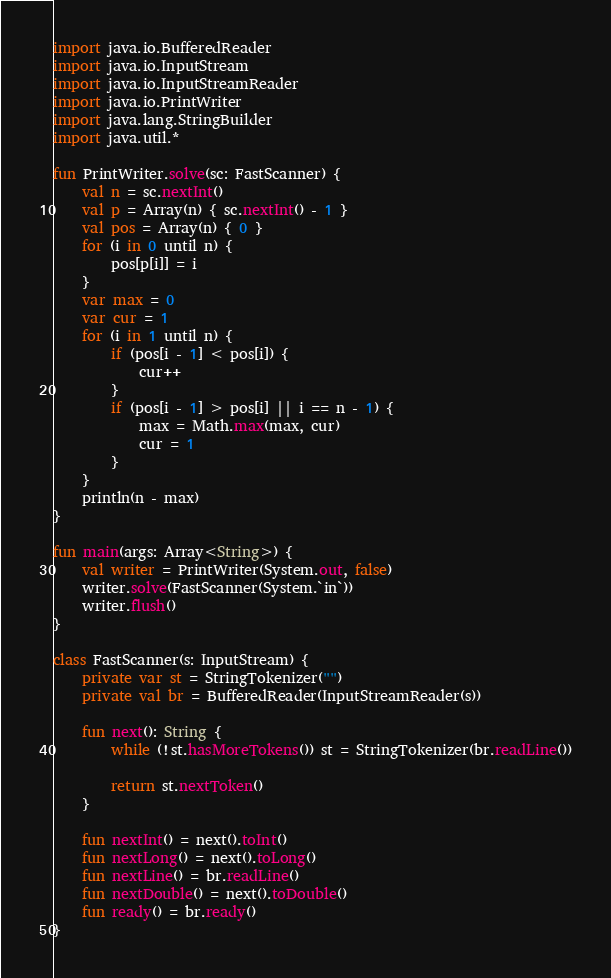<code> <loc_0><loc_0><loc_500><loc_500><_Kotlin_>import java.io.BufferedReader
import java.io.InputStream
import java.io.InputStreamReader
import java.io.PrintWriter
import java.lang.StringBuilder
import java.util.*

fun PrintWriter.solve(sc: FastScanner) {
    val n = sc.nextInt()
    val p = Array(n) { sc.nextInt() - 1 }
    val pos = Array(n) { 0 }
    for (i in 0 until n) {
        pos[p[i]] = i
    }
    var max = 0
    var cur = 1
    for (i in 1 until n) {
        if (pos[i - 1] < pos[i]) {
            cur++
        }
        if (pos[i - 1] > pos[i] || i == n - 1) {
            max = Math.max(max, cur)
            cur = 1
        }
    }
    println(n - max)
}

fun main(args: Array<String>) {
    val writer = PrintWriter(System.out, false)
    writer.solve(FastScanner(System.`in`))
    writer.flush()
}

class FastScanner(s: InputStream) {
    private var st = StringTokenizer("")
    private val br = BufferedReader(InputStreamReader(s))

    fun next(): String {
        while (!st.hasMoreTokens()) st = StringTokenizer(br.readLine())

        return st.nextToken()
    }

    fun nextInt() = next().toInt()
    fun nextLong() = next().toLong()
    fun nextLine() = br.readLine()
    fun nextDouble() = next().toDouble()
    fun ready() = br.ready()
}
</code> 